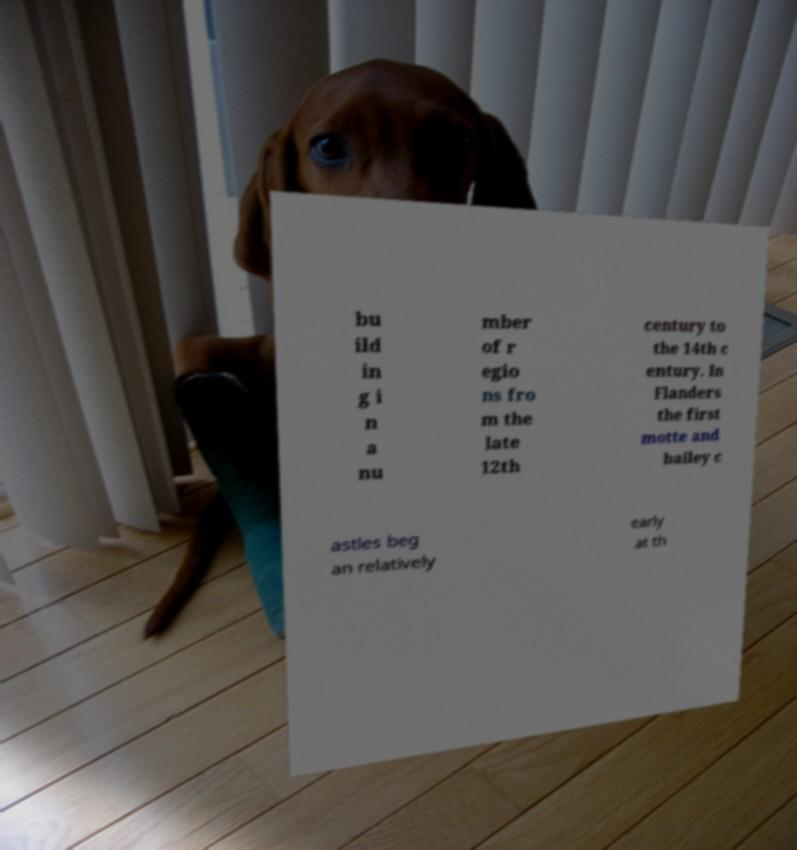Can you accurately transcribe the text from the provided image for me? bu ild in g i n a nu mber of r egio ns fro m the late 12th century to the 14th c entury. In Flanders the first motte and bailey c astles beg an relatively early at th 